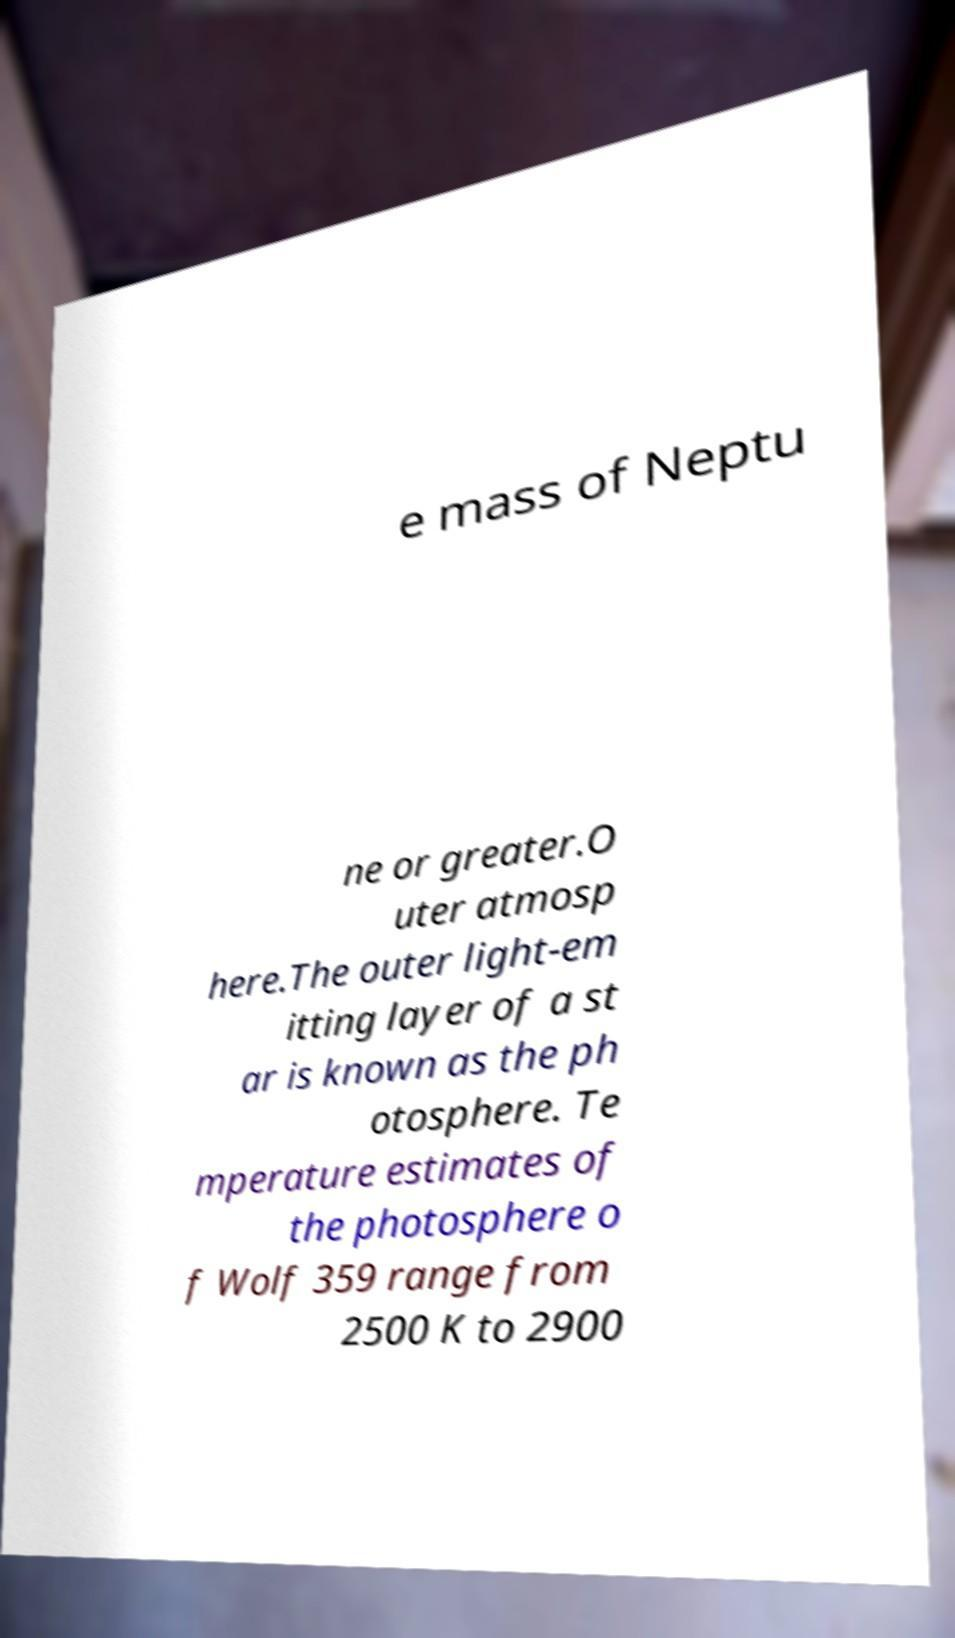There's text embedded in this image that I need extracted. Can you transcribe it verbatim? e mass of Neptu ne or greater.O uter atmosp here.The outer light-em itting layer of a st ar is known as the ph otosphere. Te mperature estimates of the photosphere o f Wolf 359 range from 2500 K to 2900 